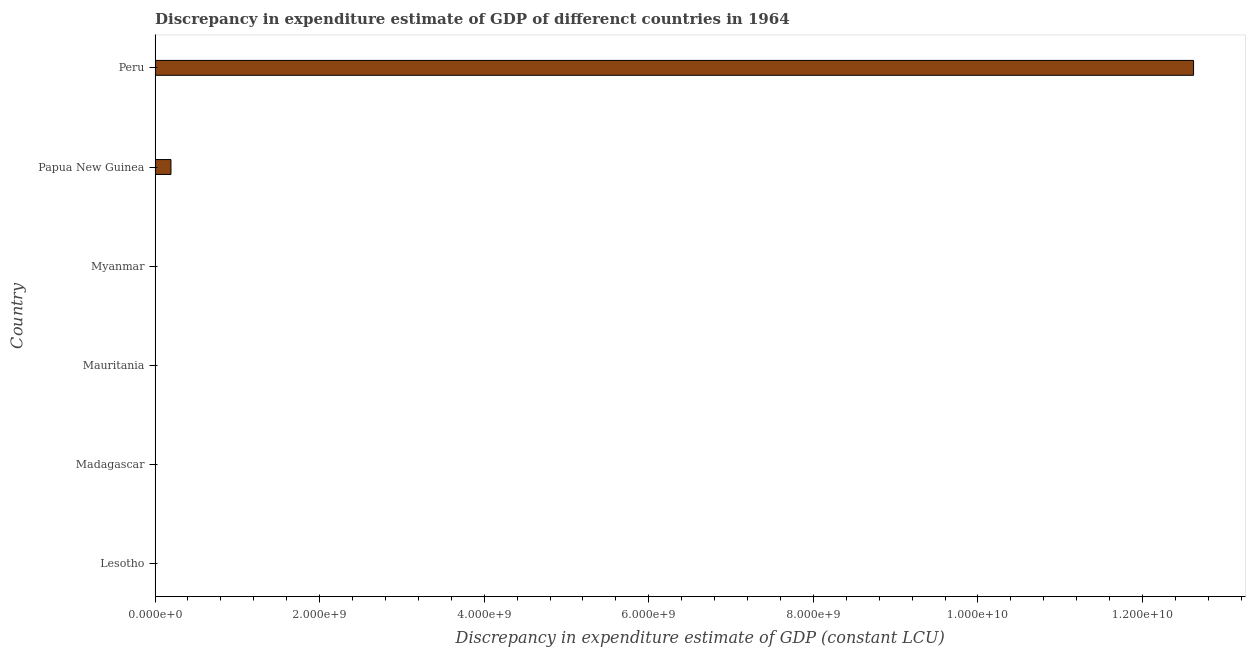What is the title of the graph?
Provide a short and direct response. Discrepancy in expenditure estimate of GDP of differenct countries in 1964. What is the label or title of the X-axis?
Your answer should be compact. Discrepancy in expenditure estimate of GDP (constant LCU). Across all countries, what is the maximum discrepancy in expenditure estimate of gdp?
Your answer should be very brief. 1.26e+1. What is the sum of the discrepancy in expenditure estimate of gdp?
Provide a succinct answer. 1.28e+1. What is the difference between the discrepancy in expenditure estimate of gdp in Papua New Guinea and Peru?
Offer a very short reply. -1.24e+1. What is the average discrepancy in expenditure estimate of gdp per country?
Provide a succinct answer. 2.14e+09. What is the median discrepancy in expenditure estimate of gdp?
Your answer should be very brief. 1.61e+06. Is the discrepancy in expenditure estimate of gdp in Madagascar less than that in Papua New Guinea?
Provide a succinct answer. Yes. What is the difference between the highest and the second highest discrepancy in expenditure estimate of gdp?
Your answer should be very brief. 1.24e+1. What is the difference between the highest and the lowest discrepancy in expenditure estimate of gdp?
Give a very brief answer. 1.26e+1. What is the Discrepancy in expenditure estimate of GDP (constant LCU) of Madagascar?
Your answer should be very brief. 3.22e+06. What is the Discrepancy in expenditure estimate of GDP (constant LCU) of Papua New Guinea?
Provide a short and direct response. 1.93e+08. What is the Discrepancy in expenditure estimate of GDP (constant LCU) of Peru?
Offer a terse response. 1.26e+1. What is the difference between the Discrepancy in expenditure estimate of GDP (constant LCU) in Madagascar and Papua New Guinea?
Your answer should be very brief. -1.90e+08. What is the difference between the Discrepancy in expenditure estimate of GDP (constant LCU) in Madagascar and Peru?
Give a very brief answer. -1.26e+1. What is the difference between the Discrepancy in expenditure estimate of GDP (constant LCU) in Papua New Guinea and Peru?
Your response must be concise. -1.24e+1. What is the ratio of the Discrepancy in expenditure estimate of GDP (constant LCU) in Madagascar to that in Papua New Guinea?
Your answer should be compact. 0.02. What is the ratio of the Discrepancy in expenditure estimate of GDP (constant LCU) in Papua New Guinea to that in Peru?
Make the answer very short. 0.01. 